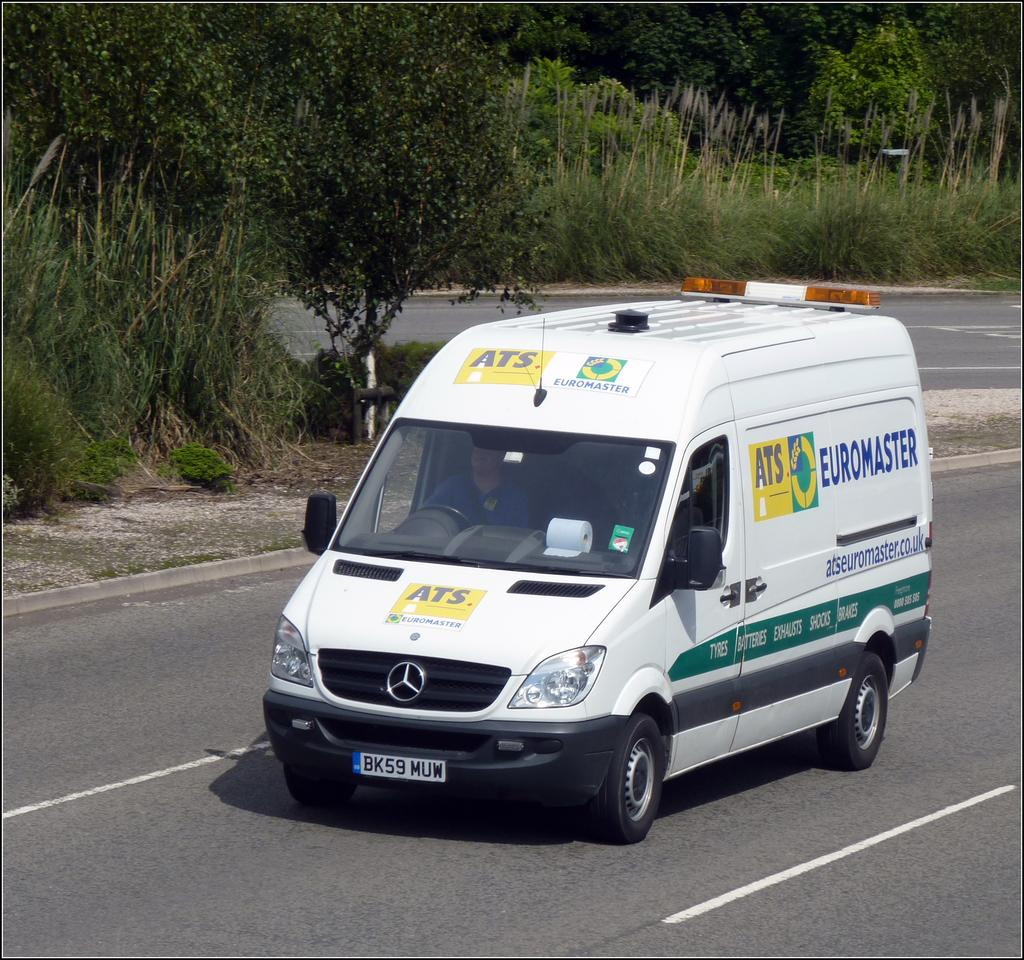What is the main subject of the image? There is a vehicle in the image. Where is the vehicle located? The vehicle is on the road. What can be seen in the surroundings of the vehicle? There are many trees around the vehicle, and grass is visible in the image. What type of skirt is the vehicle wearing in the image? Vehicles do not wear skirts; they are inanimate objects. 